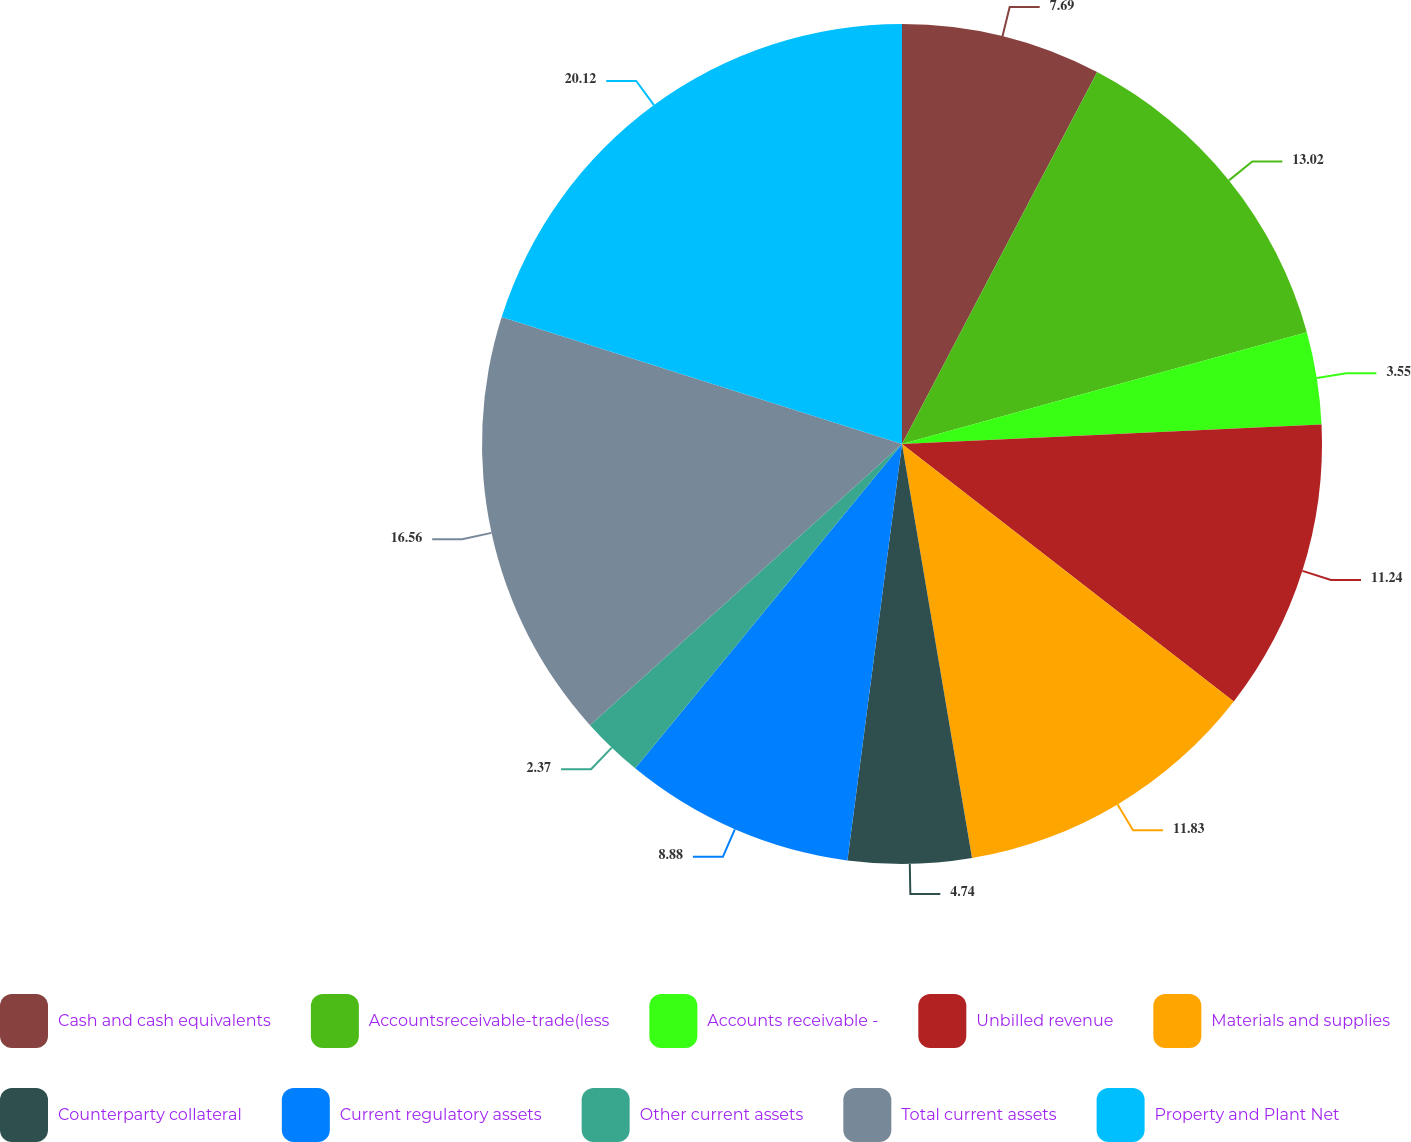<chart> <loc_0><loc_0><loc_500><loc_500><pie_chart><fcel>Cash and cash equivalents<fcel>Accountsreceivable-trade(less<fcel>Accounts receivable -<fcel>Unbilled revenue<fcel>Materials and supplies<fcel>Counterparty collateral<fcel>Current regulatory assets<fcel>Other current assets<fcel>Total current assets<fcel>Property and Plant Net<nl><fcel>7.69%<fcel>13.02%<fcel>3.55%<fcel>11.24%<fcel>11.83%<fcel>4.74%<fcel>8.88%<fcel>2.37%<fcel>16.56%<fcel>20.11%<nl></chart> 